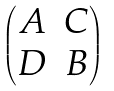Convert formula to latex. <formula><loc_0><loc_0><loc_500><loc_500>\begin{pmatrix} A & C \\ D & B \end{pmatrix}</formula> 